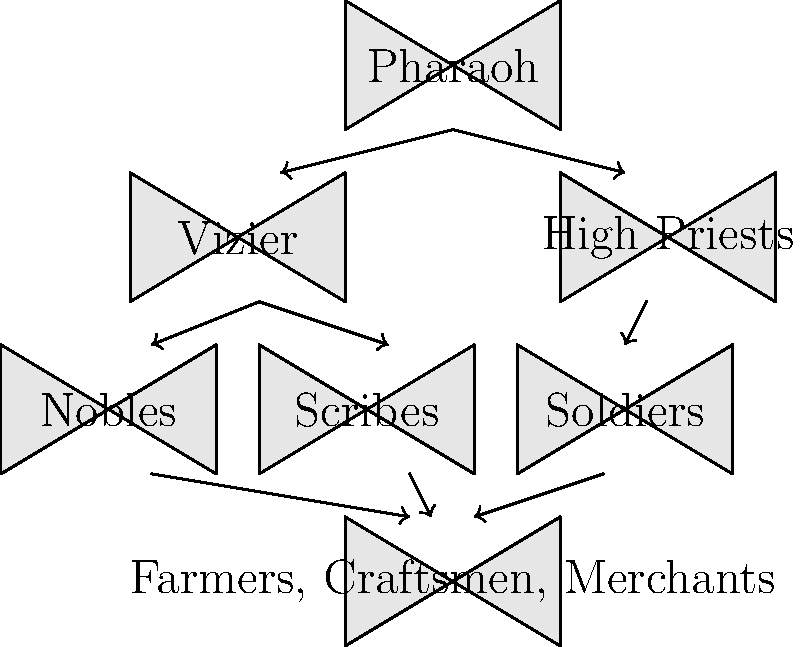Based on the organizational chart of ancient Egyptian society, which group formed the largest portion of the population and was essential for the economy but had the least political power? To answer this question, let's analyze the organizational chart step-by-step:

1. The chart shows a hierarchical structure of ancient Egyptian society.
2. At the top is the Pharaoh, who held supreme power.
3. Below the Pharaoh are the Vizier and High Priests, representing the highest levels of administration and religious authority.
4. The next level includes Nobles, Scribes, and Soldiers, who formed the educated and military classes.
5. At the bottom of the chart, we see "Farmers, Craftsmen, Merchants" grouped together.

This bottom group is significant for several reasons:
a) Their position at the base of the pyramid indicates they were the most numerous.
b) These occupations were crucial for the economy:
   - Farmers produced food
   - Craftsmen created goods
   - Merchants facilitated trade

However, their position at the bottom also indicates they had the least political power in the society.

Therefore, the group that formed the largest portion of the population, was essential for the economy, but had the least political power was the farmers, craftsmen, and merchants.
Answer: Farmers, craftsmen, and merchants 